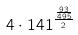<formula> <loc_0><loc_0><loc_500><loc_500>4 \cdot 1 4 1 ^ { \frac { \frac { 9 3 } { 4 9 5 } } { 2 } }</formula> 